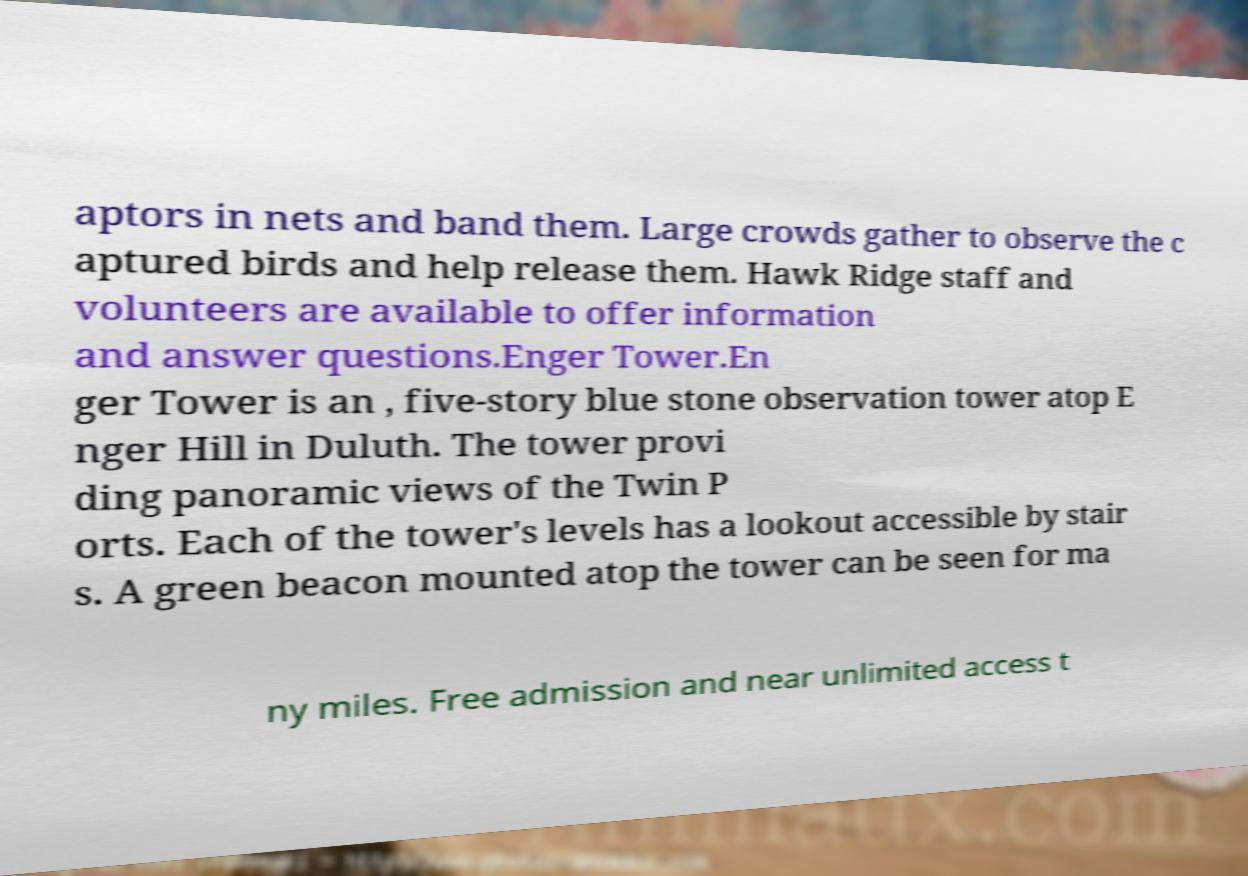Can you read and provide the text displayed in the image?This photo seems to have some interesting text. Can you extract and type it out for me? aptors in nets and band them. Large crowds gather to observe the c aptured birds and help release them. Hawk Ridge staff and volunteers are available to offer information and answer questions.Enger Tower.En ger Tower is an , five-story blue stone observation tower atop E nger Hill in Duluth. The tower provi ding panoramic views of the Twin P orts. Each of the tower's levels has a lookout accessible by stair s. A green beacon mounted atop the tower can be seen for ma ny miles. Free admission and near unlimited access t 